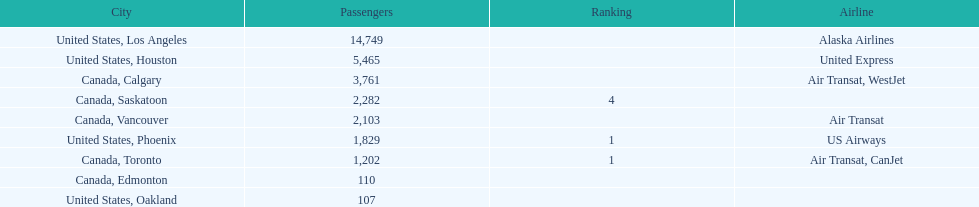How many more passengers flew to los angeles than to saskatoon from manzanillo airport in 2013? 12,467. 